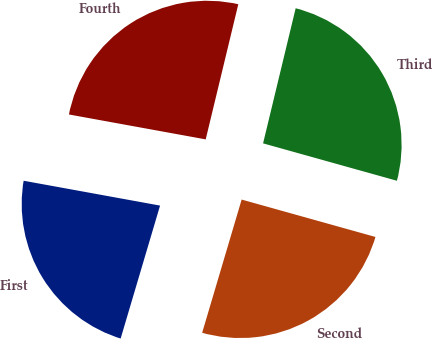Convert chart to OTSL. <chart><loc_0><loc_0><loc_500><loc_500><pie_chart><fcel>First<fcel>Second<fcel>Third<fcel>Fourth<nl><fcel>23.28%<fcel>25.25%<fcel>25.57%<fcel>25.9%<nl></chart> 